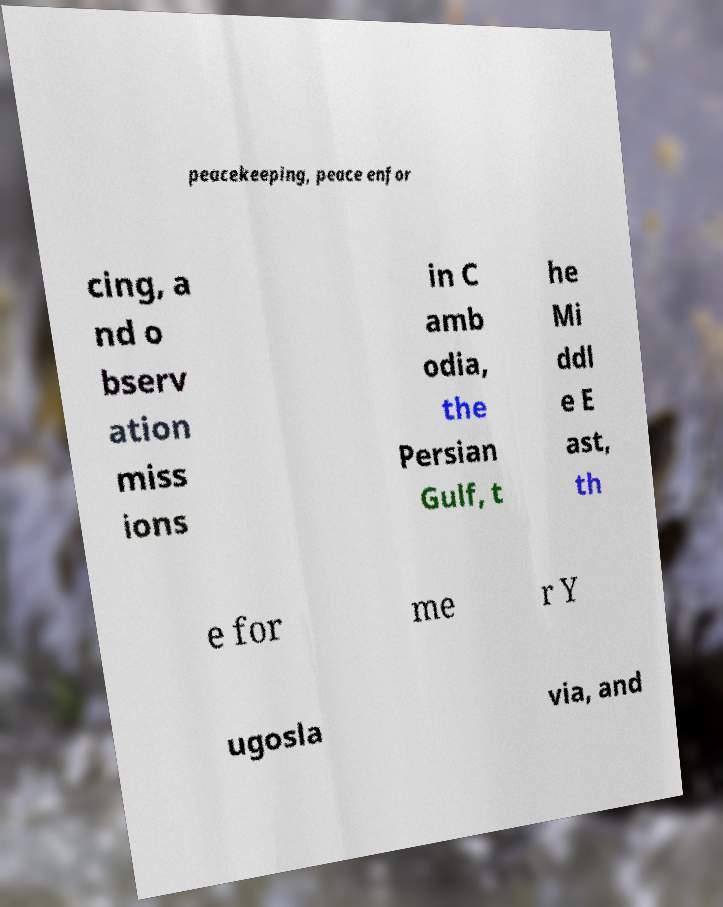What messages or text are displayed in this image? I need them in a readable, typed format. peacekeeping, peace enfor cing, a nd o bserv ation miss ions in C amb odia, the Persian Gulf, t he Mi ddl e E ast, th e for me r Y ugosla via, and 